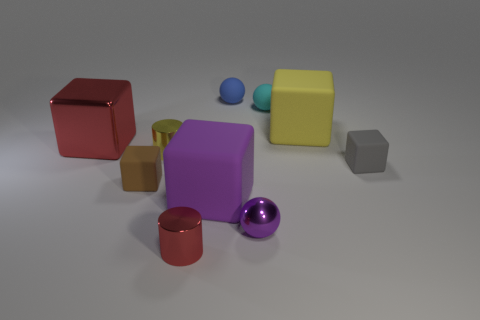What number of metallic objects are either small brown spheres or balls?
Keep it short and to the point. 1. What is the color of the other large matte object that is the same shape as the purple rubber thing?
Ensure brevity in your answer.  Yellow. What number of things are small purple blocks or big metallic objects?
Provide a succinct answer. 1. What is the shape of the small red thing that is made of the same material as the tiny purple ball?
Make the answer very short. Cylinder. How many large things are cyan rubber balls or brown rubber blocks?
Ensure brevity in your answer.  0. What number of big metal objects are right of the red metal thing that is behind the tiny cylinder that is right of the tiny yellow metallic object?
Provide a succinct answer. 0. There is a thing that is to the left of the brown block; is it the same size as the cyan matte object?
Give a very brief answer. No. Is the number of small gray things to the left of the blue matte object less than the number of big objects behind the yellow metal cylinder?
Your answer should be compact. Yes. Are there fewer big purple cubes that are on the right side of the small cyan ball than big shiny things?
Your answer should be compact. Yes. There is a large object that is the same color as the metal sphere; what is its material?
Offer a very short reply. Rubber. 